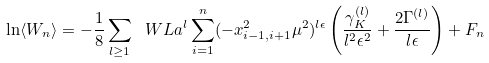<formula> <loc_0><loc_0><loc_500><loc_500>\ln \langle W _ { n } \rangle = - \frac { 1 } { 8 } \sum _ { l \geq 1 } \ W L a ^ { l } \sum _ { i = 1 } ^ { n } ( - x _ { i - 1 , i + 1 } ^ { 2 } \mu ^ { 2 } ) ^ { l \epsilon } \left ( \frac { \gamma _ { K } ^ { ( l ) } } { l ^ { 2 } \epsilon ^ { 2 } } + \frac { 2 \Gamma ^ { ( l ) } } { l \epsilon } \right ) + F _ { n }</formula> 